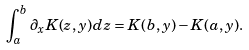<formula> <loc_0><loc_0><loc_500><loc_500>\int _ { a } ^ { b } \partial _ { x } K ( z , y ) d z = K ( b , y ) - K ( a , y ) .</formula> 